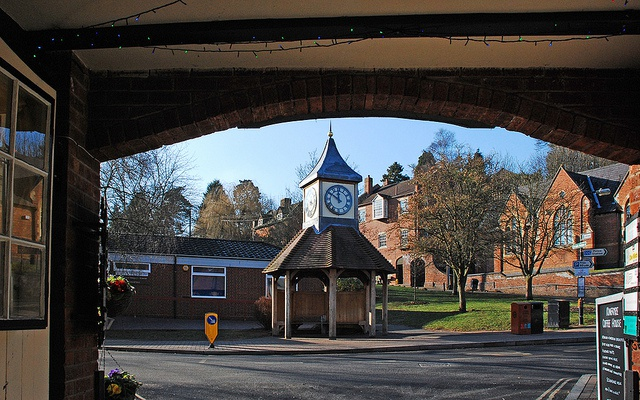Describe the objects in this image and their specific colors. I can see clock in black, gray, navy, and blue tones and clock in black, white, darkgray, gray, and lightgray tones in this image. 